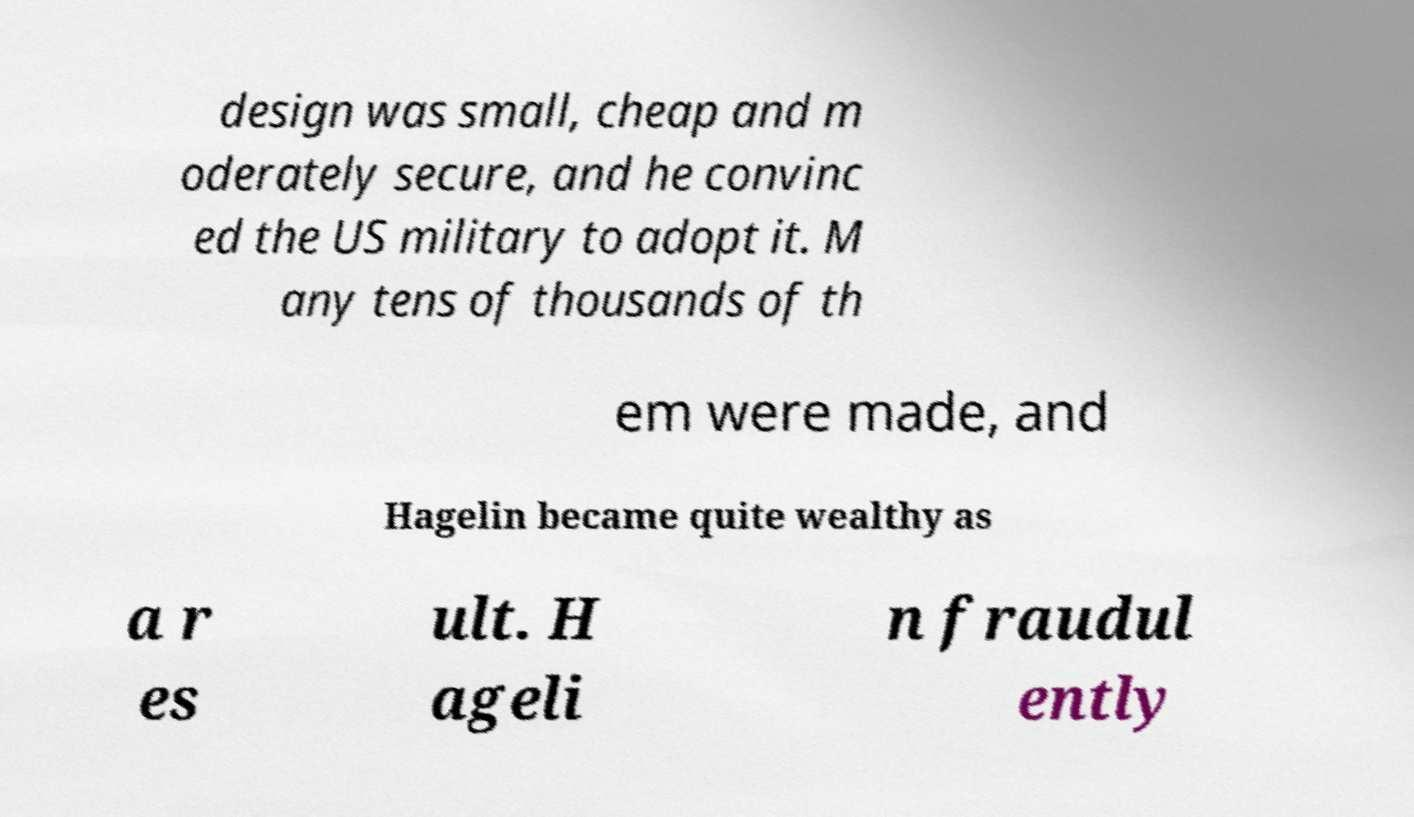What messages or text are displayed in this image? I need them in a readable, typed format. design was small, cheap and m oderately secure, and he convinc ed the US military to adopt it. M any tens of thousands of th em were made, and Hagelin became quite wealthy as a r es ult. H ageli n fraudul ently 